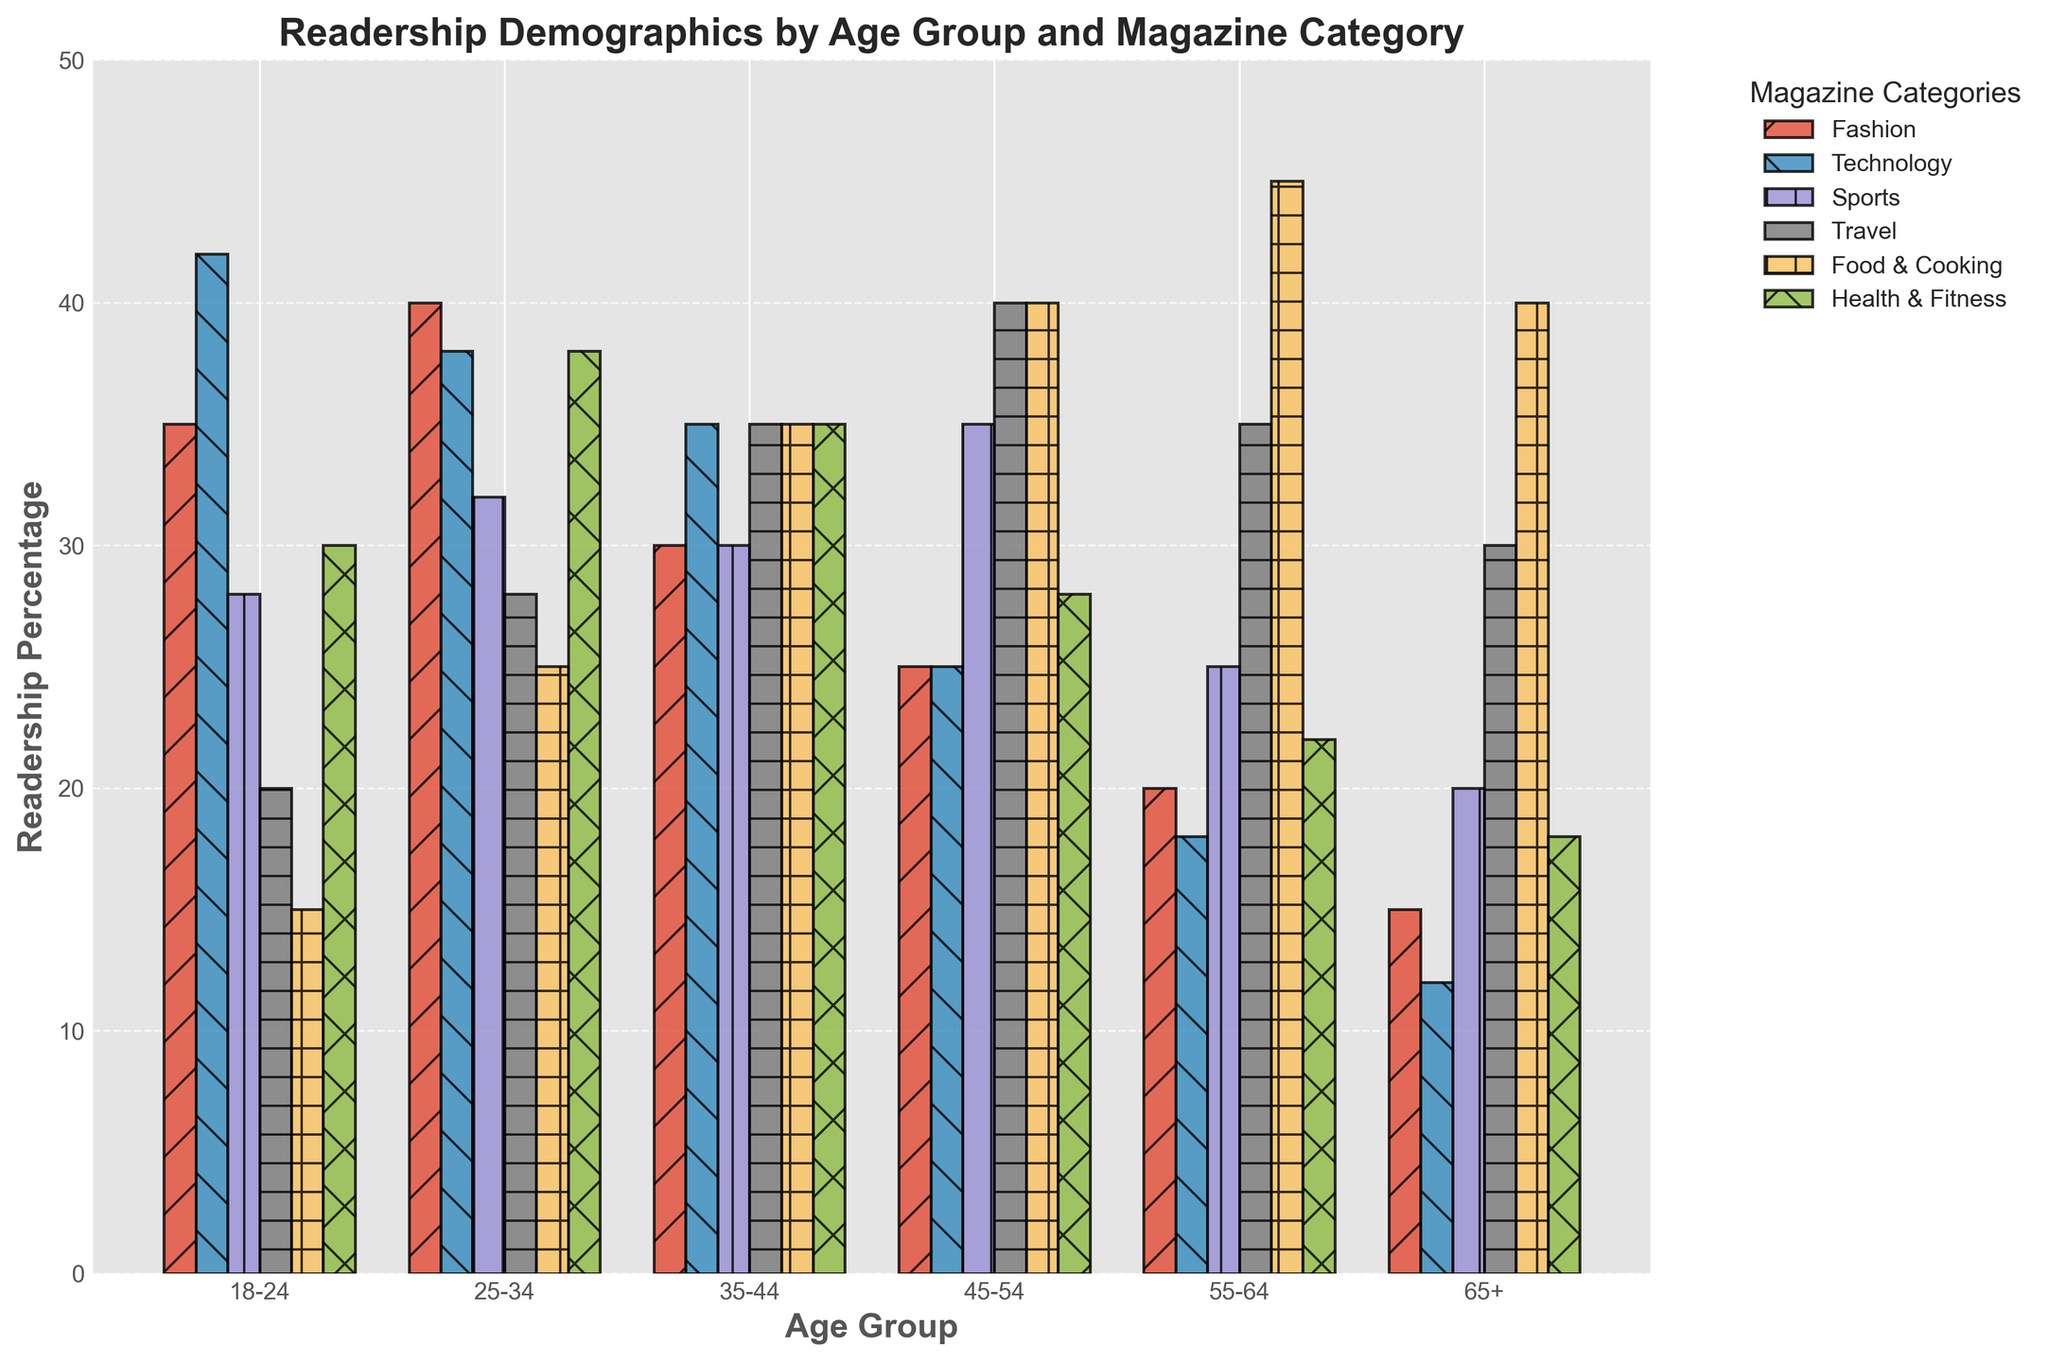Which age group has the highest readership in the Food & Cooking category? By looking at the height of the bars for the Food & Cooking category, we see that the tallest bar belongs to the 55-64 age group.
Answer: 55-64 Compare the readership percentage of the Technology and Sports categories for the 18-24 age group. Which is higher? For the 18-24 age group, the bar for Technology reads 42, while the bar for Sports reads 28. Comparing these two, Technology has a higher readership percentage.
Answer: Technology What is the total readership percentage for the Fashion category across all age groups? To get the total, sum the readership percentages for the Fashion category across all age groups: 35 (18-24) + 40 (25-34) + 30 (35-44) + 25 (45-54) + 20 (55-64) + 15 (65+). This gives 165.
Answer: 165 How does the readership for the Health & Fitness category change from the 25-34 age group to the 45-54 age group? The readership for the Health & Fitness category in the 25-34 age group is 38, and it changes to 28 for the 45-54 age group. The difference is 38 - 28 = 10.
Answer: Decreases by 10 Which magazine category has the lowest readership among the 65+ age group? The lowest bar for the 65+ age group is for the Technology category, which shows a value of 12.
Answer: Technology Of the 35-44 age group, which categories have equal readership percentages, and what are those percentages? In the 35-44 age group, the categories Technology, Sports, and Health & Fitness all have equal readership percentages of 35.
Answer: Technology, Sports, and Health & Fitness; 35 What is the average readership percentage for the Travel category across all age groups? Sum the readership percentages for the Travel category across all age groups: 20 (18-24) + 28 (25-34) + 35 (35-44) + 40 (45-54) + 35 (55-64) + 30 (65+). This gives 188, and there are 6 age groups. The average is 188 / 6 ≈ 31.33.
Answer: 31.33 For the 25-34 age group, by how much does the readership percentage of the Fashion category exceed the Food & Cooking category? For the 25-34 age group, the readership for the Fashion category is 40, and the readership for the Food & Cooking category is 25. The difference is 40 - 25 = 15.
Answer: 15 